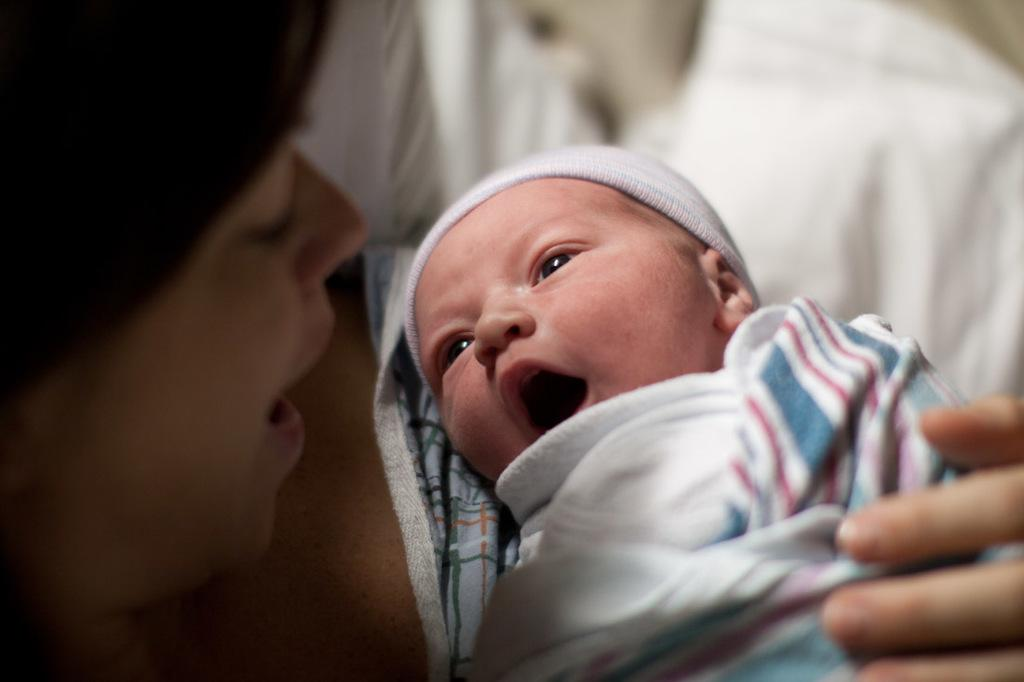What is the main subject of the image? There is a baby in the image. How is the baby dressed or covered in the image? The baby is wrapped in a cloth. What is the baby's position in the image? The baby is laying on a person. What type of agreement is being discussed by the governor and the rat in the image? There is no governor or rat present in the image; it features a baby wrapped in a cloth and laying on a person. 